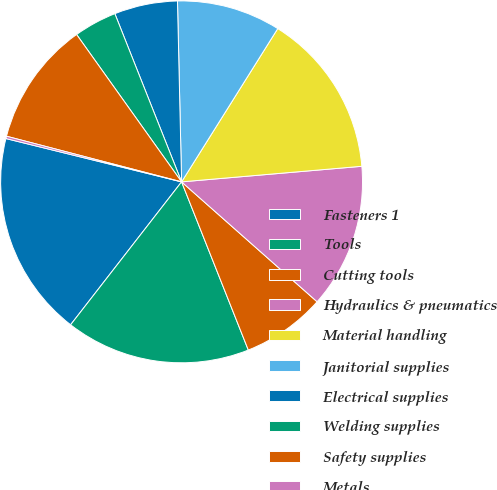Convert chart to OTSL. <chart><loc_0><loc_0><loc_500><loc_500><pie_chart><fcel>Fasteners 1<fcel>Tools<fcel>Cutting tools<fcel>Hydraulics & pneumatics<fcel>Material handling<fcel>Janitorial supplies<fcel>Electrical supplies<fcel>Welding supplies<fcel>Safety supplies<fcel>Metals<nl><fcel>18.34%<fcel>16.52%<fcel>7.46%<fcel>12.9%<fcel>14.71%<fcel>9.28%<fcel>5.65%<fcel>3.84%<fcel>11.09%<fcel>0.21%<nl></chart> 